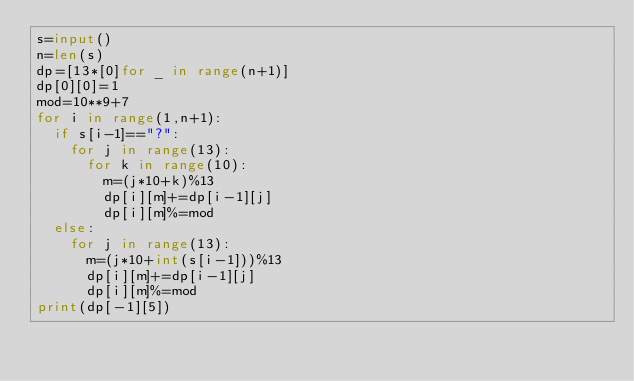<code> <loc_0><loc_0><loc_500><loc_500><_Python_>s=input()
n=len(s)
dp=[13*[0]for _ in range(n+1)]
dp[0][0]=1
mod=10**9+7
for i in range(1,n+1):
  if s[i-1]=="?":
    for j in range(13):
      for k in range(10):
        m=(j*10+k)%13
        dp[i][m]+=dp[i-1][j]
        dp[i][m]%=mod
  else:
    for j in range(13):
      m=(j*10+int(s[i-1]))%13
      dp[i][m]+=dp[i-1][j]
      dp[i][m]%=mod
print(dp[-1][5])</code> 